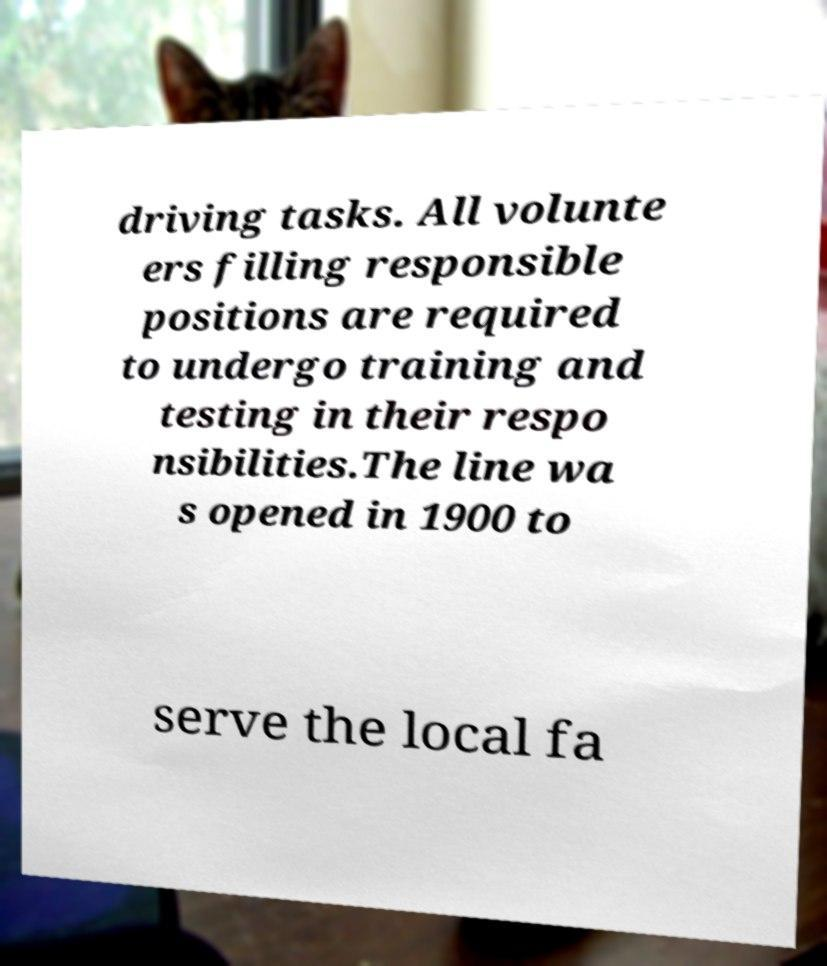What messages or text are displayed in this image? I need them in a readable, typed format. driving tasks. All volunte ers filling responsible positions are required to undergo training and testing in their respo nsibilities.The line wa s opened in 1900 to serve the local fa 